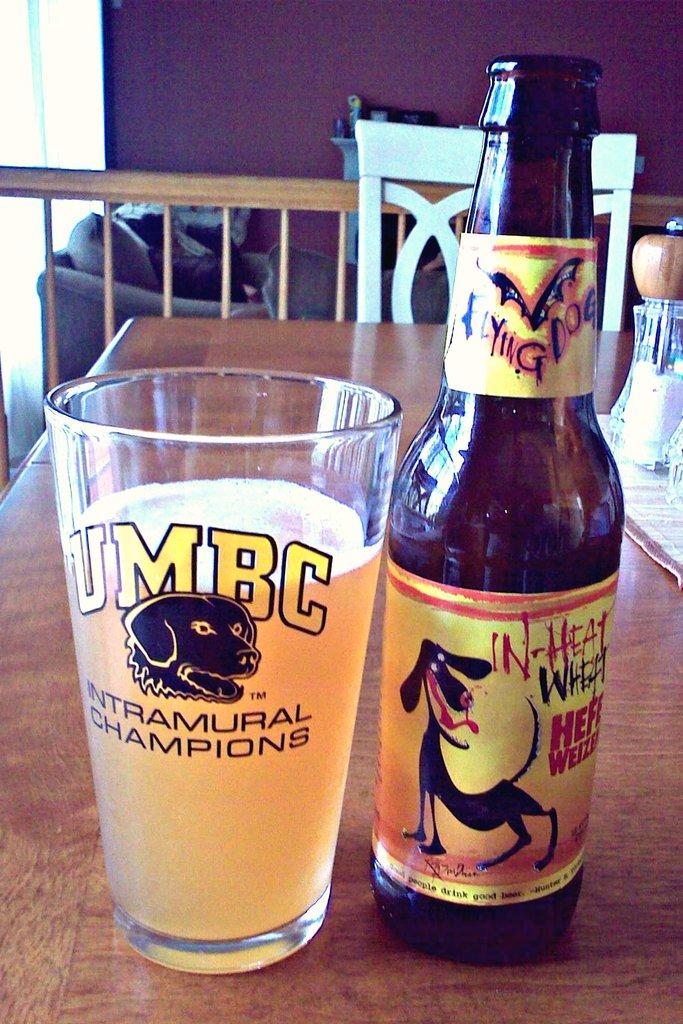<image>
Create a compact narrative representing the image presented. A beer glass displays the initials UMBC above the words INTRAMURAL CHAMPIONS. 